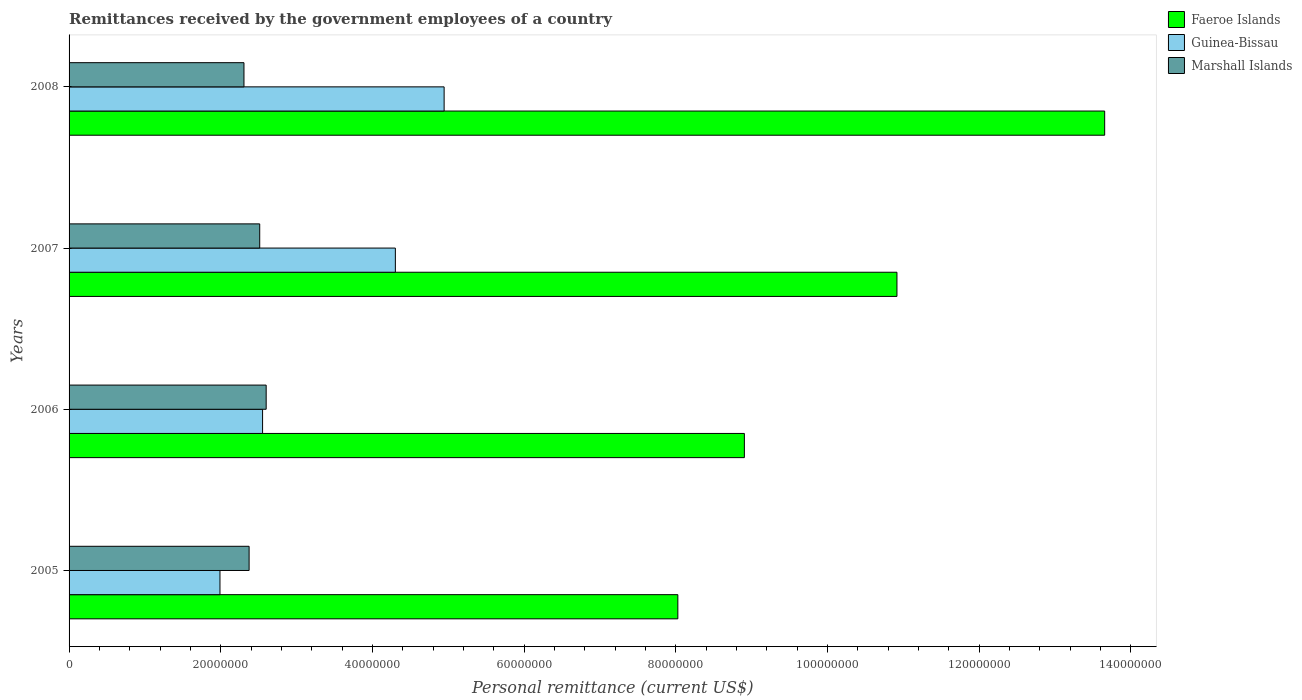How many different coloured bars are there?
Offer a very short reply. 3. Are the number of bars on each tick of the Y-axis equal?
Make the answer very short. Yes. What is the label of the 1st group of bars from the top?
Make the answer very short. 2008. What is the remittances received by the government employees in Marshall Islands in 2007?
Offer a very short reply. 2.51e+07. Across all years, what is the maximum remittances received by the government employees in Guinea-Bissau?
Make the answer very short. 4.95e+07. Across all years, what is the minimum remittances received by the government employees in Guinea-Bissau?
Give a very brief answer. 1.99e+07. What is the total remittances received by the government employees in Guinea-Bissau in the graph?
Offer a very short reply. 1.38e+08. What is the difference between the remittances received by the government employees in Guinea-Bissau in 2005 and that in 2008?
Offer a very short reply. -2.96e+07. What is the difference between the remittances received by the government employees in Marshall Islands in 2006 and the remittances received by the government employees in Faeroe Islands in 2005?
Ensure brevity in your answer.  -5.43e+07. What is the average remittances received by the government employees in Guinea-Bissau per year?
Give a very brief answer. 3.45e+07. In the year 2007, what is the difference between the remittances received by the government employees in Marshall Islands and remittances received by the government employees in Guinea-Bissau?
Your answer should be compact. -1.79e+07. In how many years, is the remittances received by the government employees in Guinea-Bissau greater than 20000000 US$?
Ensure brevity in your answer.  3. What is the ratio of the remittances received by the government employees in Marshall Islands in 2005 to that in 2008?
Your answer should be compact. 1.03. Is the remittances received by the government employees in Faeroe Islands in 2005 less than that in 2007?
Offer a very short reply. Yes. What is the difference between the highest and the second highest remittances received by the government employees in Marshall Islands?
Ensure brevity in your answer.  8.51e+05. What is the difference between the highest and the lowest remittances received by the government employees in Marshall Islands?
Your answer should be very brief. 2.93e+06. In how many years, is the remittances received by the government employees in Faeroe Islands greater than the average remittances received by the government employees in Faeroe Islands taken over all years?
Ensure brevity in your answer.  2. What does the 1st bar from the top in 2005 represents?
Your answer should be very brief. Marshall Islands. What does the 3rd bar from the bottom in 2005 represents?
Offer a terse response. Marshall Islands. Does the graph contain grids?
Keep it short and to the point. No. What is the title of the graph?
Provide a short and direct response. Remittances received by the government employees of a country. Does "Nigeria" appear as one of the legend labels in the graph?
Ensure brevity in your answer.  No. What is the label or title of the X-axis?
Offer a terse response. Personal remittance (current US$). What is the Personal remittance (current US$) in Faeroe Islands in 2005?
Offer a very short reply. 8.03e+07. What is the Personal remittance (current US$) in Guinea-Bissau in 2005?
Offer a very short reply. 1.99e+07. What is the Personal remittance (current US$) in Marshall Islands in 2005?
Your response must be concise. 2.37e+07. What is the Personal remittance (current US$) in Faeroe Islands in 2006?
Keep it short and to the point. 8.91e+07. What is the Personal remittance (current US$) in Guinea-Bissau in 2006?
Give a very brief answer. 2.55e+07. What is the Personal remittance (current US$) of Marshall Islands in 2006?
Offer a very short reply. 2.60e+07. What is the Personal remittance (current US$) of Faeroe Islands in 2007?
Keep it short and to the point. 1.09e+08. What is the Personal remittance (current US$) in Guinea-Bissau in 2007?
Make the answer very short. 4.30e+07. What is the Personal remittance (current US$) in Marshall Islands in 2007?
Give a very brief answer. 2.51e+07. What is the Personal remittance (current US$) of Faeroe Islands in 2008?
Provide a short and direct response. 1.37e+08. What is the Personal remittance (current US$) of Guinea-Bissau in 2008?
Give a very brief answer. 4.95e+07. What is the Personal remittance (current US$) of Marshall Islands in 2008?
Make the answer very short. 2.31e+07. Across all years, what is the maximum Personal remittance (current US$) of Faeroe Islands?
Provide a short and direct response. 1.37e+08. Across all years, what is the maximum Personal remittance (current US$) of Guinea-Bissau?
Provide a short and direct response. 4.95e+07. Across all years, what is the maximum Personal remittance (current US$) of Marshall Islands?
Keep it short and to the point. 2.60e+07. Across all years, what is the minimum Personal remittance (current US$) in Faeroe Islands?
Offer a terse response. 8.03e+07. Across all years, what is the minimum Personal remittance (current US$) of Guinea-Bissau?
Offer a terse response. 1.99e+07. Across all years, what is the minimum Personal remittance (current US$) of Marshall Islands?
Give a very brief answer. 2.31e+07. What is the total Personal remittance (current US$) of Faeroe Islands in the graph?
Offer a terse response. 4.15e+08. What is the total Personal remittance (current US$) in Guinea-Bissau in the graph?
Provide a succinct answer. 1.38e+08. What is the total Personal remittance (current US$) of Marshall Islands in the graph?
Your response must be concise. 9.79e+07. What is the difference between the Personal remittance (current US$) of Faeroe Islands in 2005 and that in 2006?
Provide a succinct answer. -8.77e+06. What is the difference between the Personal remittance (current US$) in Guinea-Bissau in 2005 and that in 2006?
Make the answer very short. -5.62e+06. What is the difference between the Personal remittance (current US$) of Marshall Islands in 2005 and that in 2006?
Ensure brevity in your answer.  -2.25e+06. What is the difference between the Personal remittance (current US$) of Faeroe Islands in 2005 and that in 2007?
Offer a terse response. -2.89e+07. What is the difference between the Personal remittance (current US$) of Guinea-Bissau in 2005 and that in 2007?
Offer a very short reply. -2.31e+07. What is the difference between the Personal remittance (current US$) in Marshall Islands in 2005 and that in 2007?
Your response must be concise. -1.40e+06. What is the difference between the Personal remittance (current US$) in Faeroe Islands in 2005 and that in 2008?
Make the answer very short. -5.63e+07. What is the difference between the Personal remittance (current US$) of Guinea-Bissau in 2005 and that in 2008?
Your response must be concise. -2.96e+07. What is the difference between the Personal remittance (current US$) in Marshall Islands in 2005 and that in 2008?
Your response must be concise. 6.78e+05. What is the difference between the Personal remittance (current US$) in Faeroe Islands in 2006 and that in 2007?
Your response must be concise. -2.01e+07. What is the difference between the Personal remittance (current US$) of Guinea-Bissau in 2006 and that in 2007?
Provide a short and direct response. -1.75e+07. What is the difference between the Personal remittance (current US$) of Marshall Islands in 2006 and that in 2007?
Provide a short and direct response. 8.51e+05. What is the difference between the Personal remittance (current US$) of Faeroe Islands in 2006 and that in 2008?
Keep it short and to the point. -4.75e+07. What is the difference between the Personal remittance (current US$) of Guinea-Bissau in 2006 and that in 2008?
Ensure brevity in your answer.  -2.39e+07. What is the difference between the Personal remittance (current US$) of Marshall Islands in 2006 and that in 2008?
Your answer should be very brief. 2.93e+06. What is the difference between the Personal remittance (current US$) in Faeroe Islands in 2007 and that in 2008?
Offer a very short reply. -2.74e+07. What is the difference between the Personal remittance (current US$) in Guinea-Bissau in 2007 and that in 2008?
Offer a terse response. -6.43e+06. What is the difference between the Personal remittance (current US$) in Marshall Islands in 2007 and that in 2008?
Your response must be concise. 2.08e+06. What is the difference between the Personal remittance (current US$) in Faeroe Islands in 2005 and the Personal remittance (current US$) in Guinea-Bissau in 2006?
Offer a very short reply. 5.48e+07. What is the difference between the Personal remittance (current US$) in Faeroe Islands in 2005 and the Personal remittance (current US$) in Marshall Islands in 2006?
Your response must be concise. 5.43e+07. What is the difference between the Personal remittance (current US$) of Guinea-Bissau in 2005 and the Personal remittance (current US$) of Marshall Islands in 2006?
Your answer should be compact. -6.09e+06. What is the difference between the Personal remittance (current US$) of Faeroe Islands in 2005 and the Personal remittance (current US$) of Guinea-Bissau in 2007?
Your answer should be compact. 3.73e+07. What is the difference between the Personal remittance (current US$) in Faeroe Islands in 2005 and the Personal remittance (current US$) in Marshall Islands in 2007?
Your answer should be very brief. 5.51e+07. What is the difference between the Personal remittance (current US$) of Guinea-Bissau in 2005 and the Personal remittance (current US$) of Marshall Islands in 2007?
Provide a succinct answer. -5.24e+06. What is the difference between the Personal remittance (current US$) of Faeroe Islands in 2005 and the Personal remittance (current US$) of Guinea-Bissau in 2008?
Give a very brief answer. 3.08e+07. What is the difference between the Personal remittance (current US$) of Faeroe Islands in 2005 and the Personal remittance (current US$) of Marshall Islands in 2008?
Offer a terse response. 5.72e+07. What is the difference between the Personal remittance (current US$) of Guinea-Bissau in 2005 and the Personal remittance (current US$) of Marshall Islands in 2008?
Offer a very short reply. -3.17e+06. What is the difference between the Personal remittance (current US$) of Faeroe Islands in 2006 and the Personal remittance (current US$) of Guinea-Bissau in 2007?
Keep it short and to the point. 4.60e+07. What is the difference between the Personal remittance (current US$) of Faeroe Islands in 2006 and the Personal remittance (current US$) of Marshall Islands in 2007?
Provide a succinct answer. 6.39e+07. What is the difference between the Personal remittance (current US$) in Guinea-Bissau in 2006 and the Personal remittance (current US$) in Marshall Islands in 2007?
Offer a terse response. 3.78e+05. What is the difference between the Personal remittance (current US$) of Faeroe Islands in 2006 and the Personal remittance (current US$) of Guinea-Bissau in 2008?
Your answer should be very brief. 3.96e+07. What is the difference between the Personal remittance (current US$) of Faeroe Islands in 2006 and the Personal remittance (current US$) of Marshall Islands in 2008?
Your response must be concise. 6.60e+07. What is the difference between the Personal remittance (current US$) in Guinea-Bissau in 2006 and the Personal remittance (current US$) in Marshall Islands in 2008?
Offer a very short reply. 2.45e+06. What is the difference between the Personal remittance (current US$) of Faeroe Islands in 2007 and the Personal remittance (current US$) of Guinea-Bissau in 2008?
Give a very brief answer. 5.97e+07. What is the difference between the Personal remittance (current US$) in Faeroe Islands in 2007 and the Personal remittance (current US$) in Marshall Islands in 2008?
Make the answer very short. 8.61e+07. What is the difference between the Personal remittance (current US$) in Guinea-Bissau in 2007 and the Personal remittance (current US$) in Marshall Islands in 2008?
Provide a succinct answer. 2.00e+07. What is the average Personal remittance (current US$) of Faeroe Islands per year?
Your answer should be very brief. 1.04e+08. What is the average Personal remittance (current US$) in Guinea-Bissau per year?
Your answer should be very brief. 3.45e+07. What is the average Personal remittance (current US$) of Marshall Islands per year?
Your answer should be very brief. 2.45e+07. In the year 2005, what is the difference between the Personal remittance (current US$) of Faeroe Islands and Personal remittance (current US$) of Guinea-Bissau?
Your answer should be very brief. 6.04e+07. In the year 2005, what is the difference between the Personal remittance (current US$) in Faeroe Islands and Personal remittance (current US$) in Marshall Islands?
Your answer should be very brief. 5.65e+07. In the year 2005, what is the difference between the Personal remittance (current US$) of Guinea-Bissau and Personal remittance (current US$) of Marshall Islands?
Your answer should be very brief. -3.84e+06. In the year 2006, what is the difference between the Personal remittance (current US$) of Faeroe Islands and Personal remittance (current US$) of Guinea-Bissau?
Keep it short and to the point. 6.35e+07. In the year 2006, what is the difference between the Personal remittance (current US$) of Faeroe Islands and Personal remittance (current US$) of Marshall Islands?
Your response must be concise. 6.31e+07. In the year 2006, what is the difference between the Personal remittance (current US$) in Guinea-Bissau and Personal remittance (current US$) in Marshall Islands?
Ensure brevity in your answer.  -4.74e+05. In the year 2007, what is the difference between the Personal remittance (current US$) of Faeroe Islands and Personal remittance (current US$) of Guinea-Bissau?
Provide a short and direct response. 6.61e+07. In the year 2007, what is the difference between the Personal remittance (current US$) of Faeroe Islands and Personal remittance (current US$) of Marshall Islands?
Your response must be concise. 8.40e+07. In the year 2007, what is the difference between the Personal remittance (current US$) of Guinea-Bissau and Personal remittance (current US$) of Marshall Islands?
Give a very brief answer. 1.79e+07. In the year 2008, what is the difference between the Personal remittance (current US$) in Faeroe Islands and Personal remittance (current US$) in Guinea-Bissau?
Give a very brief answer. 8.71e+07. In the year 2008, what is the difference between the Personal remittance (current US$) in Faeroe Islands and Personal remittance (current US$) in Marshall Islands?
Your answer should be compact. 1.14e+08. In the year 2008, what is the difference between the Personal remittance (current US$) in Guinea-Bissau and Personal remittance (current US$) in Marshall Islands?
Provide a succinct answer. 2.64e+07. What is the ratio of the Personal remittance (current US$) in Faeroe Islands in 2005 to that in 2006?
Ensure brevity in your answer.  0.9. What is the ratio of the Personal remittance (current US$) of Guinea-Bissau in 2005 to that in 2006?
Provide a succinct answer. 0.78. What is the ratio of the Personal remittance (current US$) in Marshall Islands in 2005 to that in 2006?
Your answer should be very brief. 0.91. What is the ratio of the Personal remittance (current US$) of Faeroe Islands in 2005 to that in 2007?
Provide a succinct answer. 0.74. What is the ratio of the Personal remittance (current US$) of Guinea-Bissau in 2005 to that in 2007?
Keep it short and to the point. 0.46. What is the ratio of the Personal remittance (current US$) in Marshall Islands in 2005 to that in 2007?
Provide a succinct answer. 0.94. What is the ratio of the Personal remittance (current US$) of Faeroe Islands in 2005 to that in 2008?
Your answer should be compact. 0.59. What is the ratio of the Personal remittance (current US$) in Guinea-Bissau in 2005 to that in 2008?
Keep it short and to the point. 0.4. What is the ratio of the Personal remittance (current US$) in Marshall Islands in 2005 to that in 2008?
Offer a terse response. 1.03. What is the ratio of the Personal remittance (current US$) of Faeroe Islands in 2006 to that in 2007?
Make the answer very short. 0.82. What is the ratio of the Personal remittance (current US$) in Guinea-Bissau in 2006 to that in 2007?
Your answer should be very brief. 0.59. What is the ratio of the Personal remittance (current US$) in Marshall Islands in 2006 to that in 2007?
Offer a very short reply. 1.03. What is the ratio of the Personal remittance (current US$) of Faeroe Islands in 2006 to that in 2008?
Offer a terse response. 0.65. What is the ratio of the Personal remittance (current US$) of Guinea-Bissau in 2006 to that in 2008?
Make the answer very short. 0.52. What is the ratio of the Personal remittance (current US$) of Marshall Islands in 2006 to that in 2008?
Offer a terse response. 1.13. What is the ratio of the Personal remittance (current US$) in Faeroe Islands in 2007 to that in 2008?
Offer a very short reply. 0.8. What is the ratio of the Personal remittance (current US$) in Guinea-Bissau in 2007 to that in 2008?
Your answer should be compact. 0.87. What is the ratio of the Personal remittance (current US$) of Marshall Islands in 2007 to that in 2008?
Provide a short and direct response. 1.09. What is the difference between the highest and the second highest Personal remittance (current US$) of Faeroe Islands?
Your response must be concise. 2.74e+07. What is the difference between the highest and the second highest Personal remittance (current US$) of Guinea-Bissau?
Offer a terse response. 6.43e+06. What is the difference between the highest and the second highest Personal remittance (current US$) of Marshall Islands?
Give a very brief answer. 8.51e+05. What is the difference between the highest and the lowest Personal remittance (current US$) in Faeroe Islands?
Your answer should be compact. 5.63e+07. What is the difference between the highest and the lowest Personal remittance (current US$) of Guinea-Bissau?
Keep it short and to the point. 2.96e+07. What is the difference between the highest and the lowest Personal remittance (current US$) in Marshall Islands?
Make the answer very short. 2.93e+06. 